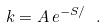Convert formula to latex. <formula><loc_0><loc_0><loc_500><loc_500>k = A \, e ^ { - S / } \ .</formula> 